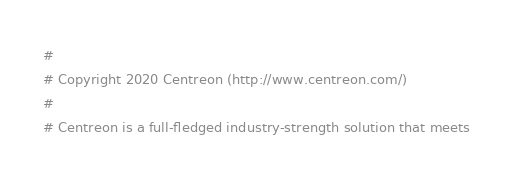<code> <loc_0><loc_0><loc_500><loc_500><_Perl_>#
# Copyright 2020 Centreon (http://www.centreon.com/)
#
# Centreon is a full-fledged industry-strength solution that meets</code> 